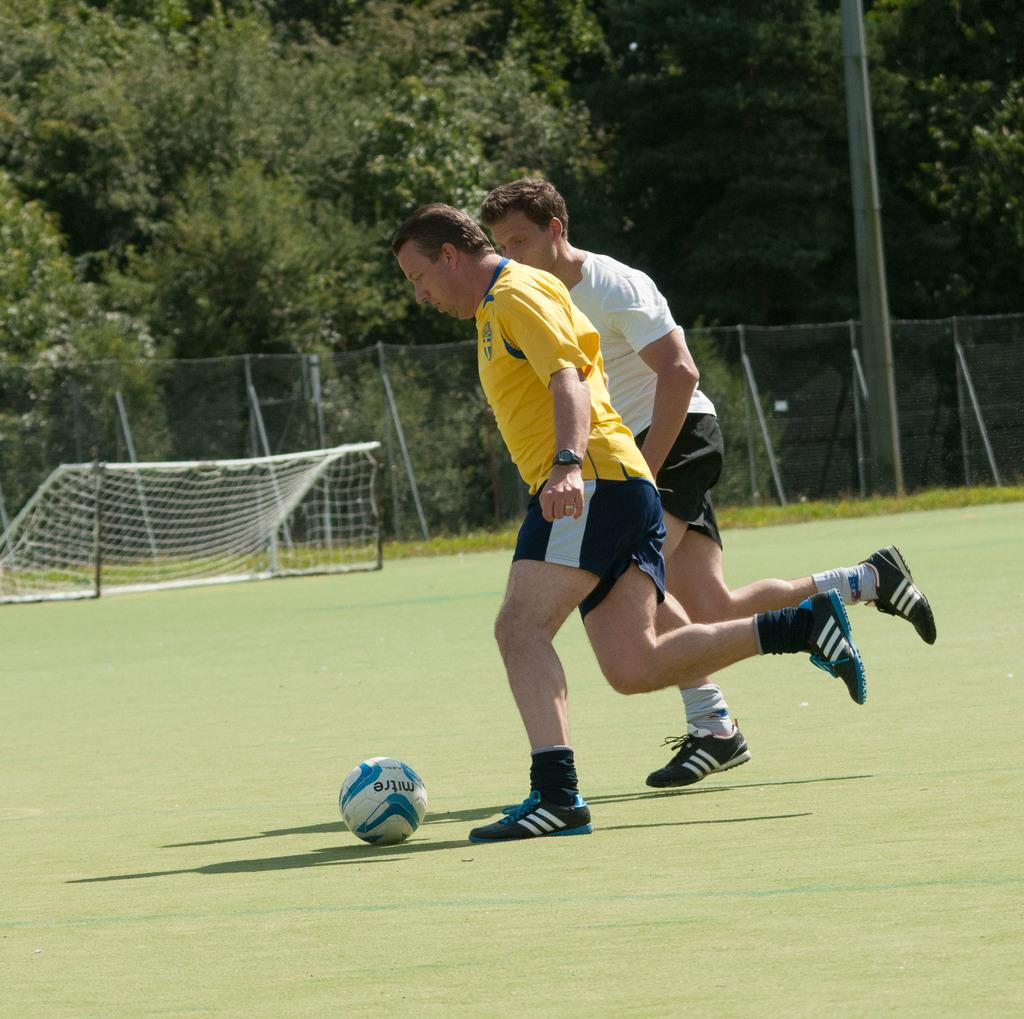How many people are present in the image? There are two people in the image. What object is on the ground in the image? There is a ball on the ground in the image. What can be seen in the background of the image? There are trees, a fence, a net, and a pole in the background of the image. What type of tax is being discussed by the two people in the image? There is no indication in the image that the two people are discussing any type of tax. --- Facts: 1. There is a car in the image. 2. The car is red. 3. The car has four wheels. 4. There is a road in the image. 5. The road is paved. 6. There are trees on both sides of the road. Absurd Topics: parrot, dance, ocean Conversation: What type of vehicle is in the image? There is a car in the image. What color is the car? The car is red. How many wheels does the car have? The car has four wheels. What is the surface of the road in the image? The road is paved. What can be seen on both sides of the road in the image? There are trees on both sides of the road. Reasoning: Let's think step by step in order to produce the conversation. We start by identifying the main subject in the image, which is the car. Then, we describe the color and number of wheels of the car. Next, we mention the road and its paved surface. Finally, we describe the trees on both sides of the road. Each question is designed to elicit a specific detail about the image that is known from the provided facts. Absurd Question/Answer: Can you tell me how many parrots are sitting on the car in the image? There are no parrots present in the image; it only features a red car with four wheels on a paved road with trees on both sides. 